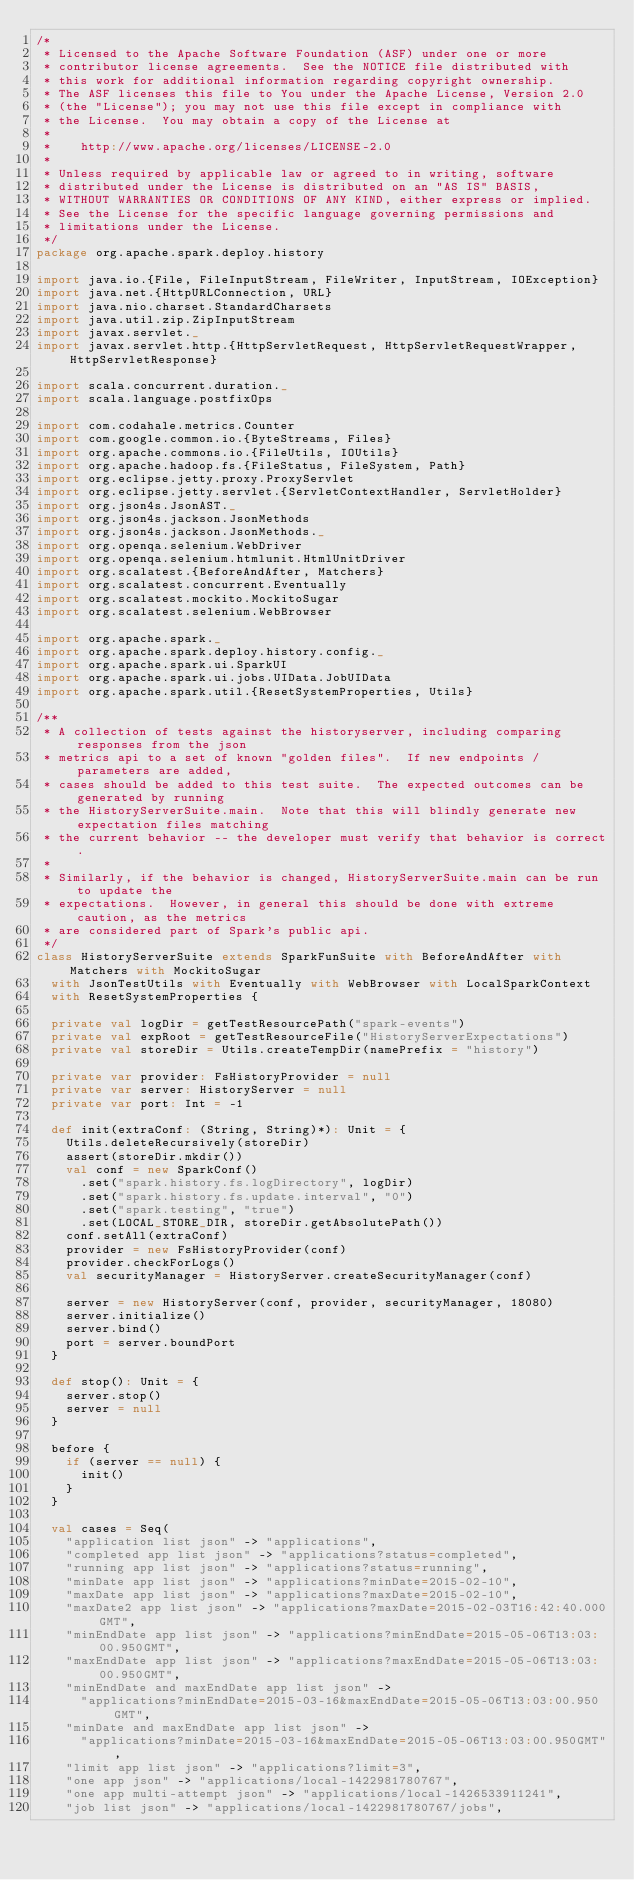Convert code to text. <code><loc_0><loc_0><loc_500><loc_500><_Scala_>/*
 * Licensed to the Apache Software Foundation (ASF) under one or more
 * contributor license agreements.  See the NOTICE file distributed with
 * this work for additional information regarding copyright ownership.
 * The ASF licenses this file to You under the Apache License, Version 2.0
 * (the "License"); you may not use this file except in compliance with
 * the License.  You may obtain a copy of the License at
 *
 *    http://www.apache.org/licenses/LICENSE-2.0
 *
 * Unless required by applicable law or agreed to in writing, software
 * distributed under the License is distributed on an "AS IS" BASIS,
 * WITHOUT WARRANTIES OR CONDITIONS OF ANY KIND, either express or implied.
 * See the License for the specific language governing permissions and
 * limitations under the License.
 */
package org.apache.spark.deploy.history

import java.io.{File, FileInputStream, FileWriter, InputStream, IOException}
import java.net.{HttpURLConnection, URL}
import java.nio.charset.StandardCharsets
import java.util.zip.ZipInputStream
import javax.servlet._
import javax.servlet.http.{HttpServletRequest, HttpServletRequestWrapper, HttpServletResponse}

import scala.concurrent.duration._
import scala.language.postfixOps

import com.codahale.metrics.Counter
import com.google.common.io.{ByteStreams, Files}
import org.apache.commons.io.{FileUtils, IOUtils}
import org.apache.hadoop.fs.{FileStatus, FileSystem, Path}
import org.eclipse.jetty.proxy.ProxyServlet
import org.eclipse.jetty.servlet.{ServletContextHandler, ServletHolder}
import org.json4s.JsonAST._
import org.json4s.jackson.JsonMethods
import org.json4s.jackson.JsonMethods._
import org.openqa.selenium.WebDriver
import org.openqa.selenium.htmlunit.HtmlUnitDriver
import org.scalatest.{BeforeAndAfter, Matchers}
import org.scalatest.concurrent.Eventually
import org.scalatest.mockito.MockitoSugar
import org.scalatest.selenium.WebBrowser

import org.apache.spark._
import org.apache.spark.deploy.history.config._
import org.apache.spark.ui.SparkUI
import org.apache.spark.ui.jobs.UIData.JobUIData
import org.apache.spark.util.{ResetSystemProperties, Utils}

/**
 * A collection of tests against the historyserver, including comparing responses from the json
 * metrics api to a set of known "golden files".  If new endpoints / parameters are added,
 * cases should be added to this test suite.  The expected outcomes can be generated by running
 * the HistoryServerSuite.main.  Note that this will blindly generate new expectation files matching
 * the current behavior -- the developer must verify that behavior is correct.
 *
 * Similarly, if the behavior is changed, HistoryServerSuite.main can be run to update the
 * expectations.  However, in general this should be done with extreme caution, as the metrics
 * are considered part of Spark's public api.
 */
class HistoryServerSuite extends SparkFunSuite with BeforeAndAfter with Matchers with MockitoSugar
  with JsonTestUtils with Eventually with WebBrowser with LocalSparkContext
  with ResetSystemProperties {

  private val logDir = getTestResourcePath("spark-events")
  private val expRoot = getTestResourceFile("HistoryServerExpectations")
  private val storeDir = Utils.createTempDir(namePrefix = "history")

  private var provider: FsHistoryProvider = null
  private var server: HistoryServer = null
  private var port: Int = -1

  def init(extraConf: (String, String)*): Unit = {
    Utils.deleteRecursively(storeDir)
    assert(storeDir.mkdir())
    val conf = new SparkConf()
      .set("spark.history.fs.logDirectory", logDir)
      .set("spark.history.fs.update.interval", "0")
      .set("spark.testing", "true")
      .set(LOCAL_STORE_DIR, storeDir.getAbsolutePath())
    conf.setAll(extraConf)
    provider = new FsHistoryProvider(conf)
    provider.checkForLogs()
    val securityManager = HistoryServer.createSecurityManager(conf)

    server = new HistoryServer(conf, provider, securityManager, 18080)
    server.initialize()
    server.bind()
    port = server.boundPort
  }

  def stop(): Unit = {
    server.stop()
    server = null
  }

  before {
    if (server == null) {
      init()
    }
  }

  val cases = Seq(
    "application list json" -> "applications",
    "completed app list json" -> "applications?status=completed",
    "running app list json" -> "applications?status=running",
    "minDate app list json" -> "applications?minDate=2015-02-10",
    "maxDate app list json" -> "applications?maxDate=2015-02-10",
    "maxDate2 app list json" -> "applications?maxDate=2015-02-03T16:42:40.000GMT",
    "minEndDate app list json" -> "applications?minEndDate=2015-05-06T13:03:00.950GMT",
    "maxEndDate app list json" -> "applications?maxEndDate=2015-05-06T13:03:00.950GMT",
    "minEndDate and maxEndDate app list json" ->
      "applications?minEndDate=2015-03-16&maxEndDate=2015-05-06T13:03:00.950GMT",
    "minDate and maxEndDate app list json" ->
      "applications?minDate=2015-03-16&maxEndDate=2015-05-06T13:03:00.950GMT",
    "limit app list json" -> "applications?limit=3",
    "one app json" -> "applications/local-1422981780767",
    "one app multi-attempt json" -> "applications/local-1426533911241",
    "job list json" -> "applications/local-1422981780767/jobs",</code> 